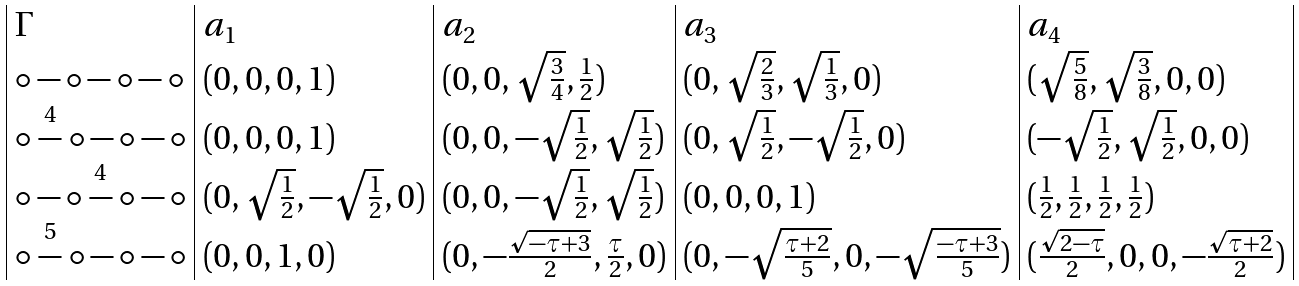Convert formula to latex. <formula><loc_0><loc_0><loc_500><loc_500>\begin{array} { | l | l | l | l | l | } \Gamma & a _ { 1 } & a _ { 2 } & a _ { 3 } & a _ { 4 } \\ \circ - \circ - \circ - \circ & ( 0 , 0 , 0 , 1 ) & ( 0 , 0 , \sqrt { \frac { 3 } { 4 } } , \frac { 1 } { 2 } ) & ( 0 , \sqrt { \frac { 2 } { 3 } } , \sqrt { \frac { 1 } { 3 } } , 0 ) & ( \sqrt { \frac { 5 } { 8 } } , \sqrt { \frac { 3 } { 8 } } , 0 , 0 ) \\ \circ \stackrel { 4 } { - } \circ - \circ - \circ & ( 0 , 0 , 0 , 1 ) & ( 0 , 0 , - \sqrt { \frac { 1 } { 2 } } , \sqrt { \frac { 1 } { 2 } } ) & ( 0 , \sqrt { \frac { 1 } { 2 } } , - \sqrt { \frac { 1 } { 2 } } , 0 ) & ( - \sqrt { \frac { 1 } { 2 } } , \sqrt { \frac { 1 } { 2 } } , 0 , 0 ) \\ \circ - \circ \stackrel { 4 } { - } \circ - \circ & ( 0 , \sqrt { \frac { 1 } { 2 } } , - \sqrt { \frac { 1 } { 2 } } , 0 ) & ( 0 , 0 , - \sqrt { \frac { 1 } { 2 } } , \sqrt { \frac { 1 } { 2 } } ) & ( 0 , 0 , 0 , 1 ) & ( \frac { 1 } { 2 } , \frac { 1 } { 2 } , \frac { 1 } { 2 } , \frac { 1 } { 2 } ) \\ \circ \stackrel { 5 } { - } \circ - \circ - \circ & ( 0 , 0 , 1 , 0 ) & ( 0 , - \frac { \sqrt { - \tau + 3 } } { 2 } , \frac { \tau } { 2 } , 0 ) & ( 0 , - \sqrt { \frac { \tau + 2 } { 5 } } , 0 , - \sqrt { \frac { - \tau + 3 } { 5 } } ) & ( \frac { \sqrt { 2 - \tau } } { 2 } , 0 , 0 , - \frac { \sqrt { \tau + 2 } } { 2 } ) \\ \end{array}</formula> 